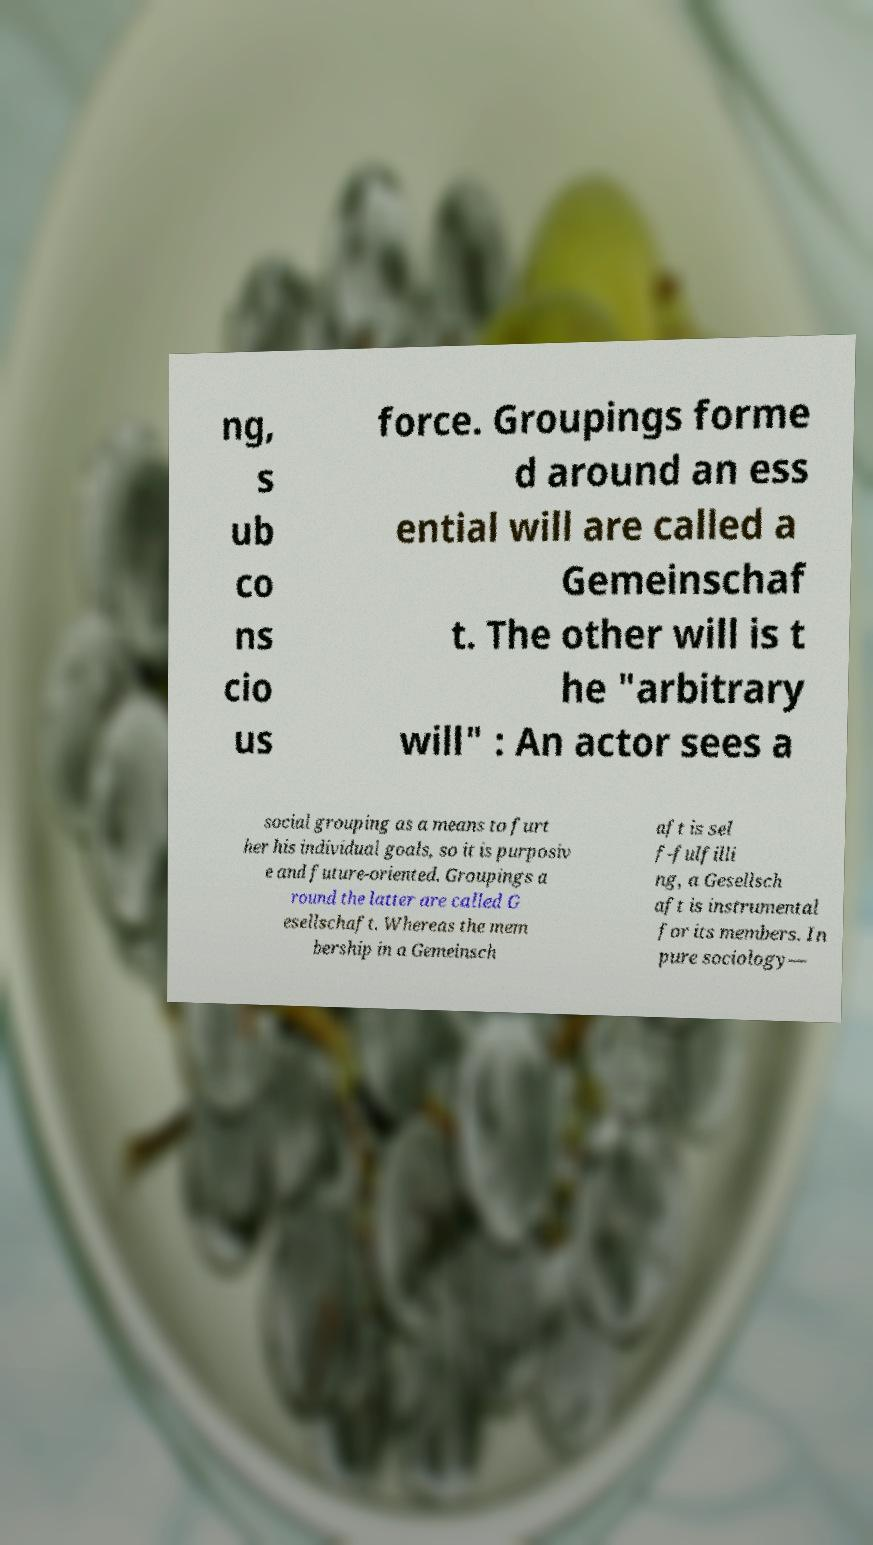Please read and relay the text visible in this image. What does it say? ng, s ub co ns cio us force. Groupings forme d around an ess ential will are called a Gemeinschaf t. The other will is t he "arbitrary will" : An actor sees a social grouping as a means to furt her his individual goals, so it is purposiv e and future-oriented. Groupings a round the latter are called G esellschaft. Whereas the mem bership in a Gemeinsch aft is sel f-fulfilli ng, a Gesellsch aft is instrumental for its members. In pure sociology— 